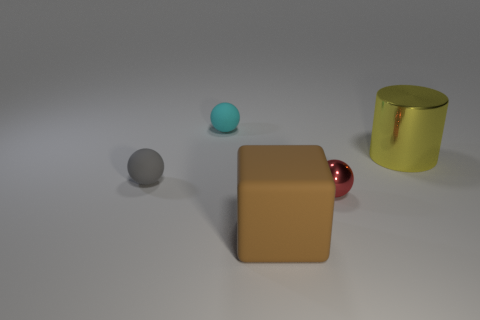What kind of setting might this image represent, and what mood does it convey? This image could represent a minimalist, perhaps conceptual setting, possibly alluding to some form of design or art installation. It conveys a tranquil and clean mood with a subtle contrast between the textures: the soft matte surface of the block, the hard shininess of the spheres, and the cylinder. The cool and warm tones of objects, along with the neutral background, create a balanced yet mysterious atmosphere, prompting curiosity about the purpose of the arrangement. 